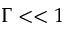<formula> <loc_0><loc_0><loc_500><loc_500>\Gamma < < 1</formula> 